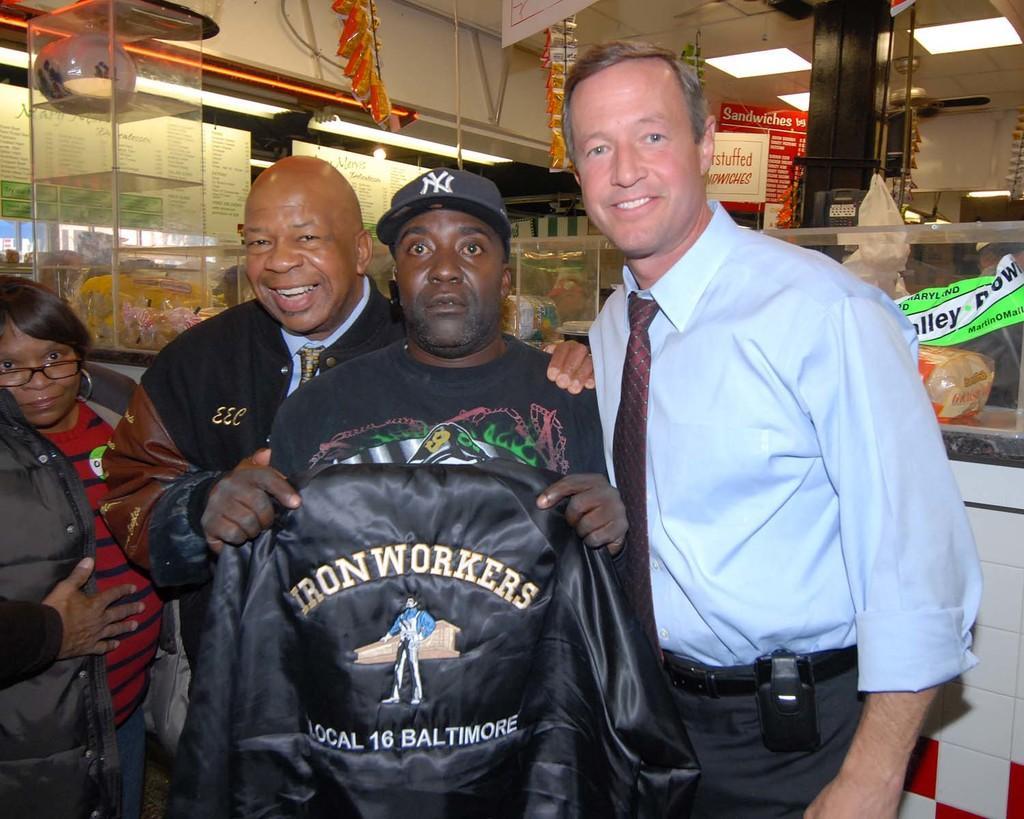How would you summarize this image in a sentence or two? In this image there are a few people standing and one of them is holding a jerkin in his hand, behind them there are a few objects placed on the platform and a few objects are hanging from the ceiling and there is a board with some text and there is another board with menu, there is a pillar and at the top of the image there is a ceiling. 